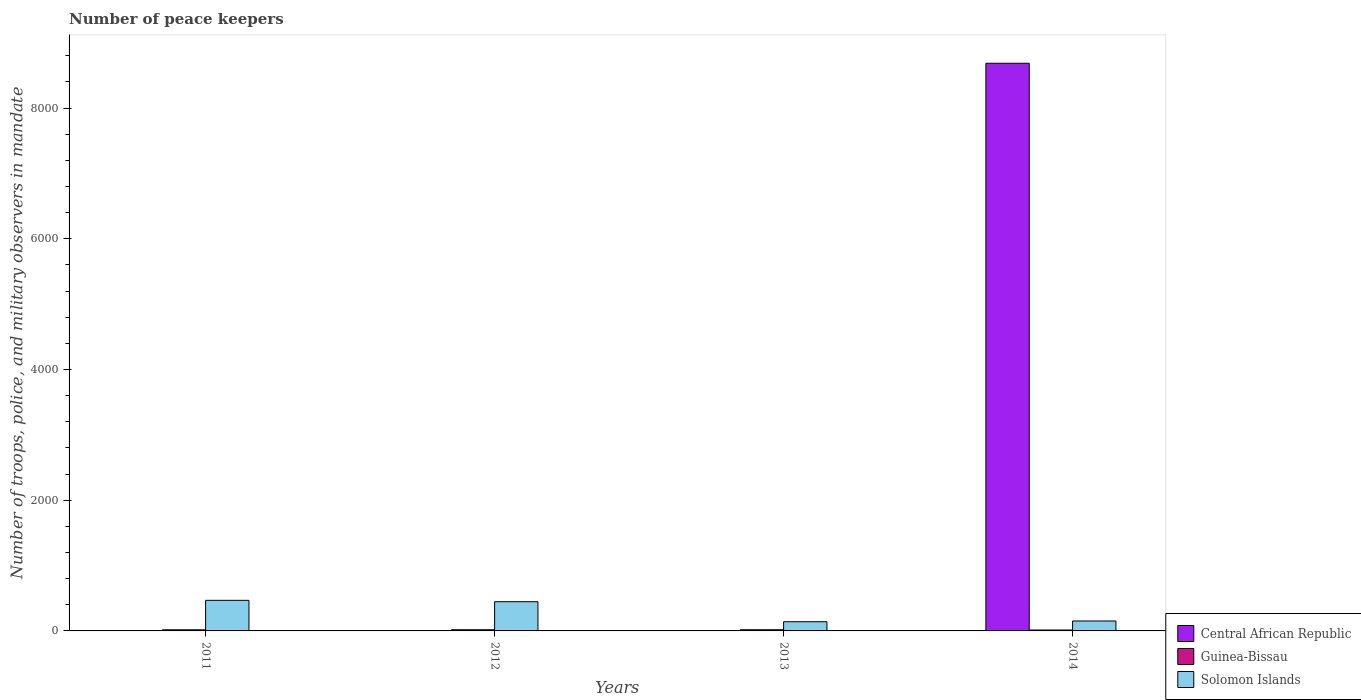How many bars are there on the 2nd tick from the left?
Your response must be concise. 3. What is the label of the 3rd group of bars from the left?
Your response must be concise. 2013. In how many cases, is the number of bars for a given year not equal to the number of legend labels?
Your answer should be very brief. 0. What is the number of peace keepers in in Solomon Islands in 2013?
Provide a succinct answer. 141. Across all years, what is the maximum number of peace keepers in in Solomon Islands?
Offer a very short reply. 468. In which year was the number of peace keepers in in Guinea-Bissau minimum?
Your answer should be very brief. 2014. What is the total number of peace keepers in in Central African Republic in the graph?
Your response must be concise. 8697. What is the difference between the number of peace keepers in in Solomon Islands in 2011 and the number of peace keepers in in Guinea-Bissau in 2014?
Offer a terse response. 454. What is the average number of peace keepers in in Guinea-Bissau per year?
Give a very brief answer. 16.75. What is the ratio of the number of peace keepers in in Solomon Islands in 2013 to that in 2014?
Give a very brief answer. 0.93. Is the number of peace keepers in in Guinea-Bissau in 2012 less than that in 2014?
Your response must be concise. No. What is the difference between the highest and the second highest number of peace keepers in in Solomon Islands?
Your answer should be compact. 21. What is the difference between the highest and the lowest number of peace keepers in in Central African Republic?
Offer a very short reply. 8681. In how many years, is the number of peace keepers in in Solomon Islands greater than the average number of peace keepers in in Solomon Islands taken over all years?
Offer a very short reply. 2. What does the 2nd bar from the left in 2014 represents?
Give a very brief answer. Guinea-Bissau. What does the 3rd bar from the right in 2014 represents?
Keep it short and to the point. Central African Republic. Are all the bars in the graph horizontal?
Provide a short and direct response. No. How many years are there in the graph?
Offer a very short reply. 4. Does the graph contain grids?
Your answer should be very brief. No. Where does the legend appear in the graph?
Your response must be concise. Bottom right. How many legend labels are there?
Provide a succinct answer. 3. How are the legend labels stacked?
Provide a succinct answer. Vertical. What is the title of the graph?
Keep it short and to the point. Number of peace keepers. What is the label or title of the Y-axis?
Your answer should be compact. Number of troops, police, and military observers in mandate. What is the Number of troops, police, and military observers in mandate in Solomon Islands in 2011?
Make the answer very short. 468. What is the Number of troops, police, and military observers in mandate of Central African Republic in 2012?
Provide a succinct answer. 4. What is the Number of troops, police, and military observers in mandate in Guinea-Bissau in 2012?
Keep it short and to the point. 18. What is the Number of troops, police, and military observers in mandate in Solomon Islands in 2012?
Make the answer very short. 447. What is the Number of troops, police, and military observers in mandate of Guinea-Bissau in 2013?
Make the answer very short. 18. What is the Number of troops, police, and military observers in mandate in Solomon Islands in 2013?
Ensure brevity in your answer.  141. What is the Number of troops, police, and military observers in mandate of Central African Republic in 2014?
Your answer should be compact. 8685. What is the Number of troops, police, and military observers in mandate in Solomon Islands in 2014?
Keep it short and to the point. 152. Across all years, what is the maximum Number of troops, police, and military observers in mandate in Central African Republic?
Ensure brevity in your answer.  8685. Across all years, what is the maximum Number of troops, police, and military observers in mandate of Solomon Islands?
Offer a terse response. 468. Across all years, what is the minimum Number of troops, police, and military observers in mandate in Central African Republic?
Offer a very short reply. 4. Across all years, what is the minimum Number of troops, police, and military observers in mandate in Guinea-Bissau?
Give a very brief answer. 14. Across all years, what is the minimum Number of troops, police, and military observers in mandate in Solomon Islands?
Your response must be concise. 141. What is the total Number of troops, police, and military observers in mandate in Central African Republic in the graph?
Offer a terse response. 8697. What is the total Number of troops, police, and military observers in mandate of Guinea-Bissau in the graph?
Your answer should be very brief. 67. What is the total Number of troops, police, and military observers in mandate in Solomon Islands in the graph?
Your answer should be compact. 1208. What is the difference between the Number of troops, police, and military observers in mandate in Central African Republic in 2011 and that in 2012?
Make the answer very short. 0. What is the difference between the Number of troops, police, and military observers in mandate in Guinea-Bissau in 2011 and that in 2012?
Ensure brevity in your answer.  -1. What is the difference between the Number of troops, police, and military observers in mandate of Central African Republic in 2011 and that in 2013?
Offer a very short reply. 0. What is the difference between the Number of troops, police, and military observers in mandate of Guinea-Bissau in 2011 and that in 2013?
Offer a terse response. -1. What is the difference between the Number of troops, police, and military observers in mandate of Solomon Islands in 2011 and that in 2013?
Give a very brief answer. 327. What is the difference between the Number of troops, police, and military observers in mandate in Central African Republic in 2011 and that in 2014?
Provide a succinct answer. -8681. What is the difference between the Number of troops, police, and military observers in mandate in Guinea-Bissau in 2011 and that in 2014?
Keep it short and to the point. 3. What is the difference between the Number of troops, police, and military observers in mandate in Solomon Islands in 2011 and that in 2014?
Your answer should be compact. 316. What is the difference between the Number of troops, police, and military observers in mandate of Central African Republic in 2012 and that in 2013?
Your answer should be very brief. 0. What is the difference between the Number of troops, police, and military observers in mandate of Solomon Islands in 2012 and that in 2013?
Your answer should be very brief. 306. What is the difference between the Number of troops, police, and military observers in mandate in Central African Republic in 2012 and that in 2014?
Your response must be concise. -8681. What is the difference between the Number of troops, police, and military observers in mandate of Guinea-Bissau in 2012 and that in 2014?
Offer a very short reply. 4. What is the difference between the Number of troops, police, and military observers in mandate of Solomon Islands in 2012 and that in 2014?
Provide a short and direct response. 295. What is the difference between the Number of troops, police, and military observers in mandate in Central African Republic in 2013 and that in 2014?
Your response must be concise. -8681. What is the difference between the Number of troops, police, and military observers in mandate in Solomon Islands in 2013 and that in 2014?
Give a very brief answer. -11. What is the difference between the Number of troops, police, and military observers in mandate in Central African Republic in 2011 and the Number of troops, police, and military observers in mandate in Solomon Islands in 2012?
Ensure brevity in your answer.  -443. What is the difference between the Number of troops, police, and military observers in mandate in Guinea-Bissau in 2011 and the Number of troops, police, and military observers in mandate in Solomon Islands in 2012?
Your answer should be compact. -430. What is the difference between the Number of troops, police, and military observers in mandate in Central African Republic in 2011 and the Number of troops, police, and military observers in mandate in Solomon Islands in 2013?
Keep it short and to the point. -137. What is the difference between the Number of troops, police, and military observers in mandate in Guinea-Bissau in 2011 and the Number of troops, police, and military observers in mandate in Solomon Islands in 2013?
Provide a succinct answer. -124. What is the difference between the Number of troops, police, and military observers in mandate of Central African Republic in 2011 and the Number of troops, police, and military observers in mandate of Solomon Islands in 2014?
Your answer should be compact. -148. What is the difference between the Number of troops, police, and military observers in mandate of Guinea-Bissau in 2011 and the Number of troops, police, and military observers in mandate of Solomon Islands in 2014?
Make the answer very short. -135. What is the difference between the Number of troops, police, and military observers in mandate of Central African Republic in 2012 and the Number of troops, police, and military observers in mandate of Solomon Islands in 2013?
Ensure brevity in your answer.  -137. What is the difference between the Number of troops, police, and military observers in mandate in Guinea-Bissau in 2012 and the Number of troops, police, and military observers in mandate in Solomon Islands in 2013?
Give a very brief answer. -123. What is the difference between the Number of troops, police, and military observers in mandate of Central African Republic in 2012 and the Number of troops, police, and military observers in mandate of Guinea-Bissau in 2014?
Provide a short and direct response. -10. What is the difference between the Number of troops, police, and military observers in mandate of Central African Republic in 2012 and the Number of troops, police, and military observers in mandate of Solomon Islands in 2014?
Ensure brevity in your answer.  -148. What is the difference between the Number of troops, police, and military observers in mandate in Guinea-Bissau in 2012 and the Number of troops, police, and military observers in mandate in Solomon Islands in 2014?
Your response must be concise. -134. What is the difference between the Number of troops, police, and military observers in mandate in Central African Republic in 2013 and the Number of troops, police, and military observers in mandate in Solomon Islands in 2014?
Give a very brief answer. -148. What is the difference between the Number of troops, police, and military observers in mandate in Guinea-Bissau in 2013 and the Number of troops, police, and military observers in mandate in Solomon Islands in 2014?
Offer a very short reply. -134. What is the average Number of troops, police, and military observers in mandate of Central African Republic per year?
Give a very brief answer. 2174.25. What is the average Number of troops, police, and military observers in mandate of Guinea-Bissau per year?
Provide a short and direct response. 16.75. What is the average Number of troops, police, and military observers in mandate of Solomon Islands per year?
Offer a terse response. 302. In the year 2011, what is the difference between the Number of troops, police, and military observers in mandate of Central African Republic and Number of troops, police, and military observers in mandate of Guinea-Bissau?
Provide a succinct answer. -13. In the year 2011, what is the difference between the Number of troops, police, and military observers in mandate in Central African Republic and Number of troops, police, and military observers in mandate in Solomon Islands?
Your answer should be very brief. -464. In the year 2011, what is the difference between the Number of troops, police, and military observers in mandate of Guinea-Bissau and Number of troops, police, and military observers in mandate of Solomon Islands?
Offer a very short reply. -451. In the year 2012, what is the difference between the Number of troops, police, and military observers in mandate of Central African Republic and Number of troops, police, and military observers in mandate of Guinea-Bissau?
Provide a succinct answer. -14. In the year 2012, what is the difference between the Number of troops, police, and military observers in mandate of Central African Republic and Number of troops, police, and military observers in mandate of Solomon Islands?
Your answer should be compact. -443. In the year 2012, what is the difference between the Number of troops, police, and military observers in mandate in Guinea-Bissau and Number of troops, police, and military observers in mandate in Solomon Islands?
Your answer should be very brief. -429. In the year 2013, what is the difference between the Number of troops, police, and military observers in mandate of Central African Republic and Number of troops, police, and military observers in mandate of Solomon Islands?
Provide a short and direct response. -137. In the year 2013, what is the difference between the Number of troops, police, and military observers in mandate in Guinea-Bissau and Number of troops, police, and military observers in mandate in Solomon Islands?
Provide a succinct answer. -123. In the year 2014, what is the difference between the Number of troops, police, and military observers in mandate of Central African Republic and Number of troops, police, and military observers in mandate of Guinea-Bissau?
Your answer should be very brief. 8671. In the year 2014, what is the difference between the Number of troops, police, and military observers in mandate of Central African Republic and Number of troops, police, and military observers in mandate of Solomon Islands?
Your answer should be very brief. 8533. In the year 2014, what is the difference between the Number of troops, police, and military observers in mandate of Guinea-Bissau and Number of troops, police, and military observers in mandate of Solomon Islands?
Keep it short and to the point. -138. What is the ratio of the Number of troops, police, and military observers in mandate in Central African Republic in 2011 to that in 2012?
Keep it short and to the point. 1. What is the ratio of the Number of troops, police, and military observers in mandate in Solomon Islands in 2011 to that in 2012?
Give a very brief answer. 1.05. What is the ratio of the Number of troops, police, and military observers in mandate of Central African Republic in 2011 to that in 2013?
Provide a succinct answer. 1. What is the ratio of the Number of troops, police, and military observers in mandate of Solomon Islands in 2011 to that in 2013?
Offer a very short reply. 3.32. What is the ratio of the Number of troops, police, and military observers in mandate in Central African Republic in 2011 to that in 2014?
Give a very brief answer. 0. What is the ratio of the Number of troops, police, and military observers in mandate of Guinea-Bissau in 2011 to that in 2014?
Provide a short and direct response. 1.21. What is the ratio of the Number of troops, police, and military observers in mandate of Solomon Islands in 2011 to that in 2014?
Keep it short and to the point. 3.08. What is the ratio of the Number of troops, police, and military observers in mandate in Solomon Islands in 2012 to that in 2013?
Provide a succinct answer. 3.17. What is the ratio of the Number of troops, police, and military observers in mandate of Guinea-Bissau in 2012 to that in 2014?
Make the answer very short. 1.29. What is the ratio of the Number of troops, police, and military observers in mandate in Solomon Islands in 2012 to that in 2014?
Provide a short and direct response. 2.94. What is the ratio of the Number of troops, police, and military observers in mandate in Central African Republic in 2013 to that in 2014?
Offer a terse response. 0. What is the ratio of the Number of troops, police, and military observers in mandate in Guinea-Bissau in 2013 to that in 2014?
Make the answer very short. 1.29. What is the ratio of the Number of troops, police, and military observers in mandate of Solomon Islands in 2013 to that in 2014?
Offer a very short reply. 0.93. What is the difference between the highest and the second highest Number of troops, police, and military observers in mandate in Central African Republic?
Ensure brevity in your answer.  8681. What is the difference between the highest and the second highest Number of troops, police, and military observers in mandate in Solomon Islands?
Offer a very short reply. 21. What is the difference between the highest and the lowest Number of troops, police, and military observers in mandate in Central African Republic?
Provide a succinct answer. 8681. What is the difference between the highest and the lowest Number of troops, police, and military observers in mandate of Guinea-Bissau?
Your answer should be compact. 4. What is the difference between the highest and the lowest Number of troops, police, and military observers in mandate in Solomon Islands?
Provide a short and direct response. 327. 